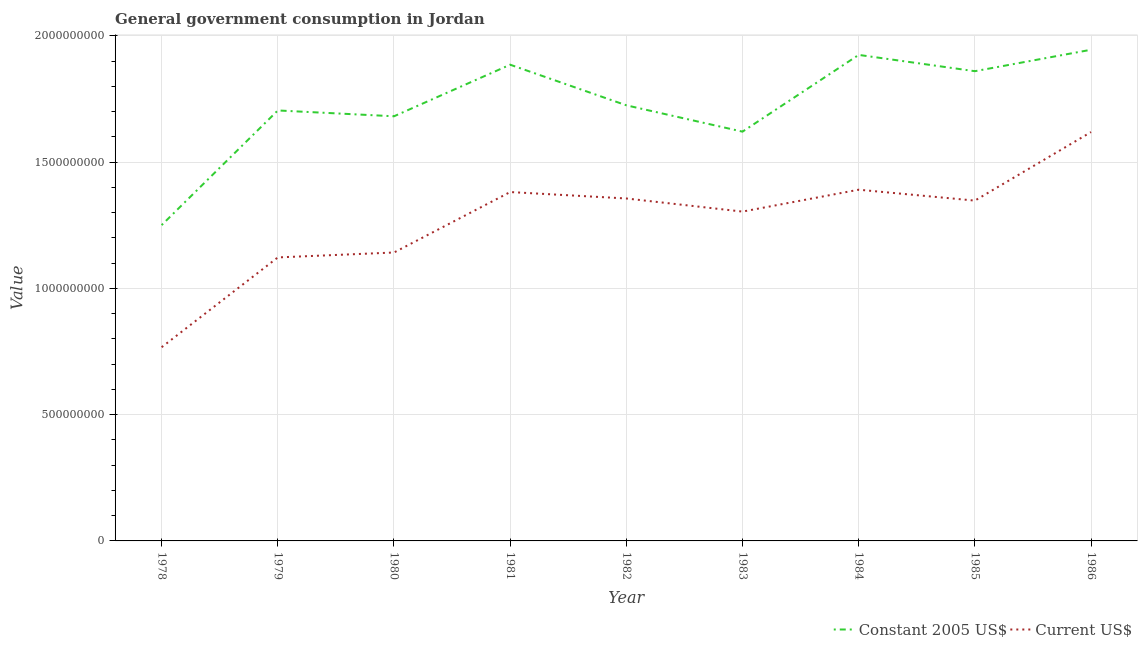Does the line corresponding to value consumed in constant 2005 us$ intersect with the line corresponding to value consumed in current us$?
Make the answer very short. No. Is the number of lines equal to the number of legend labels?
Keep it short and to the point. Yes. What is the value consumed in constant 2005 us$ in 1982?
Offer a terse response. 1.72e+09. Across all years, what is the maximum value consumed in current us$?
Ensure brevity in your answer.  1.62e+09. Across all years, what is the minimum value consumed in current us$?
Give a very brief answer. 7.67e+08. In which year was the value consumed in current us$ maximum?
Your answer should be compact. 1986. In which year was the value consumed in current us$ minimum?
Make the answer very short. 1978. What is the total value consumed in current us$ in the graph?
Ensure brevity in your answer.  1.14e+1. What is the difference between the value consumed in constant 2005 us$ in 1981 and that in 1986?
Ensure brevity in your answer.  -5.92e+07. What is the difference between the value consumed in current us$ in 1984 and the value consumed in constant 2005 us$ in 1983?
Give a very brief answer. -2.30e+08. What is the average value consumed in constant 2005 us$ per year?
Provide a short and direct response. 1.73e+09. In the year 1981, what is the difference between the value consumed in current us$ and value consumed in constant 2005 us$?
Offer a terse response. -5.04e+08. What is the ratio of the value consumed in constant 2005 us$ in 1983 to that in 1984?
Make the answer very short. 0.84. Is the value consumed in current us$ in 1978 less than that in 1979?
Provide a short and direct response. Yes. Is the difference between the value consumed in current us$ in 1979 and 1983 greater than the difference between the value consumed in constant 2005 us$ in 1979 and 1983?
Provide a short and direct response. No. What is the difference between the highest and the second highest value consumed in constant 2005 us$?
Your response must be concise. 2.04e+07. What is the difference between the highest and the lowest value consumed in constant 2005 us$?
Provide a succinct answer. 6.94e+08. Does the value consumed in constant 2005 us$ monotonically increase over the years?
Keep it short and to the point. No. Is the value consumed in constant 2005 us$ strictly greater than the value consumed in current us$ over the years?
Your response must be concise. Yes. How many lines are there?
Offer a terse response. 2. How many years are there in the graph?
Your answer should be compact. 9. What is the difference between two consecutive major ticks on the Y-axis?
Provide a short and direct response. 5.00e+08. Are the values on the major ticks of Y-axis written in scientific E-notation?
Provide a succinct answer. No. Does the graph contain any zero values?
Give a very brief answer. No. Where does the legend appear in the graph?
Make the answer very short. Bottom right. How many legend labels are there?
Give a very brief answer. 2. How are the legend labels stacked?
Ensure brevity in your answer.  Horizontal. What is the title of the graph?
Provide a succinct answer. General government consumption in Jordan. What is the label or title of the Y-axis?
Ensure brevity in your answer.  Value. What is the Value of Constant 2005 US$ in 1978?
Keep it short and to the point. 1.25e+09. What is the Value of Current US$ in 1978?
Offer a terse response. 7.67e+08. What is the Value in Constant 2005 US$ in 1979?
Provide a succinct answer. 1.70e+09. What is the Value of Current US$ in 1979?
Keep it short and to the point. 1.12e+09. What is the Value in Constant 2005 US$ in 1980?
Your answer should be very brief. 1.68e+09. What is the Value of Current US$ in 1980?
Offer a terse response. 1.14e+09. What is the Value of Constant 2005 US$ in 1981?
Provide a succinct answer. 1.89e+09. What is the Value in Current US$ in 1981?
Offer a very short reply. 1.38e+09. What is the Value of Constant 2005 US$ in 1982?
Provide a short and direct response. 1.72e+09. What is the Value of Current US$ in 1982?
Offer a terse response. 1.36e+09. What is the Value in Constant 2005 US$ in 1983?
Make the answer very short. 1.62e+09. What is the Value in Current US$ in 1983?
Provide a succinct answer. 1.30e+09. What is the Value in Constant 2005 US$ in 1984?
Offer a terse response. 1.92e+09. What is the Value in Current US$ in 1984?
Offer a terse response. 1.39e+09. What is the Value of Constant 2005 US$ in 1985?
Ensure brevity in your answer.  1.86e+09. What is the Value of Current US$ in 1985?
Offer a very short reply. 1.35e+09. What is the Value of Constant 2005 US$ in 1986?
Provide a short and direct response. 1.94e+09. What is the Value of Current US$ in 1986?
Provide a short and direct response. 1.62e+09. Across all years, what is the maximum Value in Constant 2005 US$?
Provide a succinct answer. 1.94e+09. Across all years, what is the maximum Value of Current US$?
Offer a terse response. 1.62e+09. Across all years, what is the minimum Value of Constant 2005 US$?
Make the answer very short. 1.25e+09. Across all years, what is the minimum Value in Current US$?
Keep it short and to the point. 7.67e+08. What is the total Value of Constant 2005 US$ in the graph?
Make the answer very short. 1.56e+1. What is the total Value of Current US$ in the graph?
Offer a very short reply. 1.14e+1. What is the difference between the Value in Constant 2005 US$ in 1978 and that in 1979?
Make the answer very short. -4.54e+08. What is the difference between the Value in Current US$ in 1978 and that in 1979?
Provide a short and direct response. -3.55e+08. What is the difference between the Value in Constant 2005 US$ in 1978 and that in 1980?
Provide a succinct answer. -4.31e+08. What is the difference between the Value of Current US$ in 1978 and that in 1980?
Your answer should be very brief. -3.75e+08. What is the difference between the Value in Constant 2005 US$ in 1978 and that in 1981?
Provide a short and direct response. -6.35e+08. What is the difference between the Value of Current US$ in 1978 and that in 1981?
Provide a short and direct response. -6.14e+08. What is the difference between the Value in Constant 2005 US$ in 1978 and that in 1982?
Give a very brief answer. -4.74e+08. What is the difference between the Value in Current US$ in 1978 and that in 1982?
Your response must be concise. -5.89e+08. What is the difference between the Value in Constant 2005 US$ in 1978 and that in 1983?
Ensure brevity in your answer.  -3.70e+08. What is the difference between the Value of Current US$ in 1978 and that in 1983?
Your answer should be very brief. -5.37e+08. What is the difference between the Value in Constant 2005 US$ in 1978 and that in 1984?
Offer a very short reply. -6.74e+08. What is the difference between the Value in Current US$ in 1978 and that in 1984?
Your answer should be very brief. -6.24e+08. What is the difference between the Value in Constant 2005 US$ in 1978 and that in 1985?
Ensure brevity in your answer.  -6.09e+08. What is the difference between the Value of Current US$ in 1978 and that in 1985?
Offer a terse response. -5.80e+08. What is the difference between the Value in Constant 2005 US$ in 1978 and that in 1986?
Your answer should be very brief. -6.94e+08. What is the difference between the Value in Current US$ in 1978 and that in 1986?
Provide a short and direct response. -8.52e+08. What is the difference between the Value in Constant 2005 US$ in 1979 and that in 1980?
Provide a succinct answer. 2.31e+07. What is the difference between the Value of Current US$ in 1979 and that in 1980?
Keep it short and to the point. -1.95e+07. What is the difference between the Value of Constant 2005 US$ in 1979 and that in 1981?
Provide a succinct answer. -1.81e+08. What is the difference between the Value of Current US$ in 1979 and that in 1981?
Your response must be concise. -2.59e+08. What is the difference between the Value of Constant 2005 US$ in 1979 and that in 1982?
Make the answer very short. -2.04e+07. What is the difference between the Value of Current US$ in 1979 and that in 1982?
Your response must be concise. -2.33e+08. What is the difference between the Value of Constant 2005 US$ in 1979 and that in 1983?
Provide a short and direct response. 8.39e+07. What is the difference between the Value of Current US$ in 1979 and that in 1983?
Offer a terse response. -1.81e+08. What is the difference between the Value in Constant 2005 US$ in 1979 and that in 1984?
Your response must be concise. -2.20e+08. What is the difference between the Value in Current US$ in 1979 and that in 1984?
Your response must be concise. -2.68e+08. What is the difference between the Value of Constant 2005 US$ in 1979 and that in 1985?
Your response must be concise. -1.55e+08. What is the difference between the Value in Current US$ in 1979 and that in 1985?
Keep it short and to the point. -2.25e+08. What is the difference between the Value in Constant 2005 US$ in 1979 and that in 1986?
Offer a very short reply. -2.40e+08. What is the difference between the Value in Current US$ in 1979 and that in 1986?
Provide a short and direct response. -4.96e+08. What is the difference between the Value in Constant 2005 US$ in 1980 and that in 1981?
Make the answer very short. -2.04e+08. What is the difference between the Value of Current US$ in 1980 and that in 1981?
Make the answer very short. -2.39e+08. What is the difference between the Value in Constant 2005 US$ in 1980 and that in 1982?
Your response must be concise. -4.34e+07. What is the difference between the Value of Current US$ in 1980 and that in 1982?
Ensure brevity in your answer.  -2.14e+08. What is the difference between the Value in Constant 2005 US$ in 1980 and that in 1983?
Provide a succinct answer. 6.08e+07. What is the difference between the Value in Current US$ in 1980 and that in 1983?
Ensure brevity in your answer.  -1.62e+08. What is the difference between the Value in Constant 2005 US$ in 1980 and that in 1984?
Your response must be concise. -2.43e+08. What is the difference between the Value in Current US$ in 1980 and that in 1984?
Give a very brief answer. -2.49e+08. What is the difference between the Value in Constant 2005 US$ in 1980 and that in 1985?
Your answer should be very brief. -1.79e+08. What is the difference between the Value of Current US$ in 1980 and that in 1985?
Keep it short and to the point. -2.05e+08. What is the difference between the Value of Constant 2005 US$ in 1980 and that in 1986?
Your response must be concise. -2.63e+08. What is the difference between the Value in Current US$ in 1980 and that in 1986?
Offer a terse response. -4.77e+08. What is the difference between the Value in Constant 2005 US$ in 1981 and that in 1982?
Offer a very short reply. 1.61e+08. What is the difference between the Value of Current US$ in 1981 and that in 1982?
Make the answer very short. 2.54e+07. What is the difference between the Value of Constant 2005 US$ in 1981 and that in 1983?
Keep it short and to the point. 2.65e+08. What is the difference between the Value of Current US$ in 1981 and that in 1983?
Your answer should be compact. 7.74e+07. What is the difference between the Value of Constant 2005 US$ in 1981 and that in 1984?
Keep it short and to the point. -3.88e+07. What is the difference between the Value in Current US$ in 1981 and that in 1984?
Give a very brief answer. -9.29e+06. What is the difference between the Value of Constant 2005 US$ in 1981 and that in 1985?
Provide a short and direct response. 2.57e+07. What is the difference between the Value of Current US$ in 1981 and that in 1985?
Offer a terse response. 3.39e+07. What is the difference between the Value in Constant 2005 US$ in 1981 and that in 1986?
Provide a succinct answer. -5.92e+07. What is the difference between the Value of Current US$ in 1981 and that in 1986?
Give a very brief answer. -2.38e+08. What is the difference between the Value of Constant 2005 US$ in 1982 and that in 1983?
Your answer should be very brief. 1.04e+08. What is the difference between the Value in Current US$ in 1982 and that in 1983?
Provide a succinct answer. 5.19e+07. What is the difference between the Value in Constant 2005 US$ in 1982 and that in 1984?
Your answer should be very brief. -2.00e+08. What is the difference between the Value of Current US$ in 1982 and that in 1984?
Offer a terse response. -3.47e+07. What is the difference between the Value in Constant 2005 US$ in 1982 and that in 1985?
Your answer should be compact. -1.35e+08. What is the difference between the Value of Current US$ in 1982 and that in 1985?
Your response must be concise. 8.42e+06. What is the difference between the Value in Constant 2005 US$ in 1982 and that in 1986?
Keep it short and to the point. -2.20e+08. What is the difference between the Value of Current US$ in 1982 and that in 1986?
Your answer should be compact. -2.63e+08. What is the difference between the Value of Constant 2005 US$ in 1983 and that in 1984?
Offer a very short reply. -3.04e+08. What is the difference between the Value in Current US$ in 1983 and that in 1984?
Your answer should be very brief. -8.67e+07. What is the difference between the Value in Constant 2005 US$ in 1983 and that in 1985?
Give a very brief answer. -2.39e+08. What is the difference between the Value of Current US$ in 1983 and that in 1985?
Offer a very short reply. -4.35e+07. What is the difference between the Value of Constant 2005 US$ in 1983 and that in 1986?
Your answer should be compact. -3.24e+08. What is the difference between the Value of Current US$ in 1983 and that in 1986?
Give a very brief answer. -3.15e+08. What is the difference between the Value of Constant 2005 US$ in 1984 and that in 1985?
Offer a terse response. 6.45e+07. What is the difference between the Value in Current US$ in 1984 and that in 1985?
Ensure brevity in your answer.  4.31e+07. What is the difference between the Value of Constant 2005 US$ in 1984 and that in 1986?
Provide a succinct answer. -2.04e+07. What is the difference between the Value of Current US$ in 1984 and that in 1986?
Keep it short and to the point. -2.28e+08. What is the difference between the Value of Constant 2005 US$ in 1985 and that in 1986?
Make the answer very short. -8.49e+07. What is the difference between the Value in Current US$ in 1985 and that in 1986?
Your answer should be compact. -2.71e+08. What is the difference between the Value in Constant 2005 US$ in 1978 and the Value in Current US$ in 1979?
Provide a short and direct response. 1.28e+08. What is the difference between the Value of Constant 2005 US$ in 1978 and the Value of Current US$ in 1980?
Offer a very short reply. 1.08e+08. What is the difference between the Value in Constant 2005 US$ in 1978 and the Value in Current US$ in 1981?
Your response must be concise. -1.31e+08. What is the difference between the Value in Constant 2005 US$ in 1978 and the Value in Current US$ in 1982?
Offer a very short reply. -1.05e+08. What is the difference between the Value of Constant 2005 US$ in 1978 and the Value of Current US$ in 1983?
Ensure brevity in your answer.  -5.35e+07. What is the difference between the Value in Constant 2005 US$ in 1978 and the Value in Current US$ in 1984?
Keep it short and to the point. -1.40e+08. What is the difference between the Value in Constant 2005 US$ in 1978 and the Value in Current US$ in 1985?
Your response must be concise. -9.70e+07. What is the difference between the Value of Constant 2005 US$ in 1978 and the Value of Current US$ in 1986?
Keep it short and to the point. -3.68e+08. What is the difference between the Value in Constant 2005 US$ in 1979 and the Value in Current US$ in 1980?
Provide a short and direct response. 5.62e+08. What is the difference between the Value of Constant 2005 US$ in 1979 and the Value of Current US$ in 1981?
Provide a short and direct response. 3.23e+08. What is the difference between the Value of Constant 2005 US$ in 1979 and the Value of Current US$ in 1982?
Your answer should be compact. 3.48e+08. What is the difference between the Value of Constant 2005 US$ in 1979 and the Value of Current US$ in 1983?
Ensure brevity in your answer.  4.00e+08. What is the difference between the Value in Constant 2005 US$ in 1979 and the Value in Current US$ in 1984?
Offer a terse response. 3.14e+08. What is the difference between the Value of Constant 2005 US$ in 1979 and the Value of Current US$ in 1985?
Your response must be concise. 3.57e+08. What is the difference between the Value in Constant 2005 US$ in 1979 and the Value in Current US$ in 1986?
Give a very brief answer. 8.55e+07. What is the difference between the Value of Constant 2005 US$ in 1980 and the Value of Current US$ in 1981?
Your answer should be compact. 3.00e+08. What is the difference between the Value in Constant 2005 US$ in 1980 and the Value in Current US$ in 1982?
Your answer should be compact. 3.25e+08. What is the difference between the Value of Constant 2005 US$ in 1980 and the Value of Current US$ in 1983?
Your answer should be compact. 3.77e+08. What is the difference between the Value of Constant 2005 US$ in 1980 and the Value of Current US$ in 1984?
Ensure brevity in your answer.  2.91e+08. What is the difference between the Value in Constant 2005 US$ in 1980 and the Value in Current US$ in 1985?
Your answer should be compact. 3.34e+08. What is the difference between the Value in Constant 2005 US$ in 1980 and the Value in Current US$ in 1986?
Give a very brief answer. 6.25e+07. What is the difference between the Value in Constant 2005 US$ in 1981 and the Value in Current US$ in 1982?
Your answer should be compact. 5.30e+08. What is the difference between the Value of Constant 2005 US$ in 1981 and the Value of Current US$ in 1983?
Provide a succinct answer. 5.82e+08. What is the difference between the Value in Constant 2005 US$ in 1981 and the Value in Current US$ in 1984?
Give a very brief answer. 4.95e+08. What is the difference between the Value of Constant 2005 US$ in 1981 and the Value of Current US$ in 1985?
Your response must be concise. 5.38e+08. What is the difference between the Value of Constant 2005 US$ in 1981 and the Value of Current US$ in 1986?
Offer a terse response. 2.67e+08. What is the difference between the Value in Constant 2005 US$ in 1982 and the Value in Current US$ in 1983?
Provide a short and direct response. 4.21e+08. What is the difference between the Value in Constant 2005 US$ in 1982 and the Value in Current US$ in 1984?
Provide a short and direct response. 3.34e+08. What is the difference between the Value of Constant 2005 US$ in 1982 and the Value of Current US$ in 1985?
Offer a terse response. 3.77e+08. What is the difference between the Value in Constant 2005 US$ in 1982 and the Value in Current US$ in 1986?
Make the answer very short. 1.06e+08. What is the difference between the Value in Constant 2005 US$ in 1983 and the Value in Current US$ in 1984?
Ensure brevity in your answer.  2.30e+08. What is the difference between the Value in Constant 2005 US$ in 1983 and the Value in Current US$ in 1985?
Your response must be concise. 2.73e+08. What is the difference between the Value in Constant 2005 US$ in 1983 and the Value in Current US$ in 1986?
Your answer should be very brief. 1.63e+06. What is the difference between the Value in Constant 2005 US$ in 1984 and the Value in Current US$ in 1985?
Provide a succinct answer. 5.77e+08. What is the difference between the Value of Constant 2005 US$ in 1984 and the Value of Current US$ in 1986?
Ensure brevity in your answer.  3.06e+08. What is the difference between the Value of Constant 2005 US$ in 1985 and the Value of Current US$ in 1986?
Provide a short and direct response. 2.41e+08. What is the average Value of Constant 2005 US$ per year?
Your answer should be very brief. 1.73e+09. What is the average Value in Current US$ per year?
Provide a succinct answer. 1.27e+09. In the year 1978, what is the difference between the Value of Constant 2005 US$ and Value of Current US$?
Provide a short and direct response. 4.83e+08. In the year 1979, what is the difference between the Value in Constant 2005 US$ and Value in Current US$?
Provide a succinct answer. 5.82e+08. In the year 1980, what is the difference between the Value in Constant 2005 US$ and Value in Current US$?
Your response must be concise. 5.39e+08. In the year 1981, what is the difference between the Value of Constant 2005 US$ and Value of Current US$?
Keep it short and to the point. 5.04e+08. In the year 1982, what is the difference between the Value of Constant 2005 US$ and Value of Current US$?
Provide a short and direct response. 3.69e+08. In the year 1983, what is the difference between the Value of Constant 2005 US$ and Value of Current US$?
Keep it short and to the point. 3.17e+08. In the year 1984, what is the difference between the Value in Constant 2005 US$ and Value in Current US$?
Your answer should be compact. 5.34e+08. In the year 1985, what is the difference between the Value in Constant 2005 US$ and Value in Current US$?
Your answer should be very brief. 5.12e+08. In the year 1986, what is the difference between the Value of Constant 2005 US$ and Value of Current US$?
Give a very brief answer. 3.26e+08. What is the ratio of the Value in Constant 2005 US$ in 1978 to that in 1979?
Give a very brief answer. 0.73. What is the ratio of the Value in Current US$ in 1978 to that in 1979?
Your response must be concise. 0.68. What is the ratio of the Value in Constant 2005 US$ in 1978 to that in 1980?
Provide a short and direct response. 0.74. What is the ratio of the Value of Current US$ in 1978 to that in 1980?
Your answer should be very brief. 0.67. What is the ratio of the Value in Constant 2005 US$ in 1978 to that in 1981?
Keep it short and to the point. 0.66. What is the ratio of the Value in Current US$ in 1978 to that in 1981?
Provide a succinct answer. 0.56. What is the ratio of the Value of Constant 2005 US$ in 1978 to that in 1982?
Offer a very short reply. 0.72. What is the ratio of the Value in Current US$ in 1978 to that in 1982?
Your answer should be very brief. 0.57. What is the ratio of the Value in Constant 2005 US$ in 1978 to that in 1983?
Provide a succinct answer. 0.77. What is the ratio of the Value in Current US$ in 1978 to that in 1983?
Offer a terse response. 0.59. What is the ratio of the Value in Constant 2005 US$ in 1978 to that in 1984?
Ensure brevity in your answer.  0.65. What is the ratio of the Value of Current US$ in 1978 to that in 1984?
Give a very brief answer. 0.55. What is the ratio of the Value in Constant 2005 US$ in 1978 to that in 1985?
Your answer should be very brief. 0.67. What is the ratio of the Value of Current US$ in 1978 to that in 1985?
Offer a terse response. 0.57. What is the ratio of the Value in Constant 2005 US$ in 1978 to that in 1986?
Provide a succinct answer. 0.64. What is the ratio of the Value of Current US$ in 1978 to that in 1986?
Keep it short and to the point. 0.47. What is the ratio of the Value in Constant 2005 US$ in 1979 to that in 1980?
Ensure brevity in your answer.  1.01. What is the ratio of the Value of Current US$ in 1979 to that in 1980?
Offer a terse response. 0.98. What is the ratio of the Value in Constant 2005 US$ in 1979 to that in 1981?
Your answer should be very brief. 0.9. What is the ratio of the Value of Current US$ in 1979 to that in 1981?
Your answer should be compact. 0.81. What is the ratio of the Value in Current US$ in 1979 to that in 1982?
Your answer should be compact. 0.83. What is the ratio of the Value in Constant 2005 US$ in 1979 to that in 1983?
Offer a terse response. 1.05. What is the ratio of the Value in Current US$ in 1979 to that in 1983?
Offer a very short reply. 0.86. What is the ratio of the Value in Constant 2005 US$ in 1979 to that in 1984?
Offer a terse response. 0.89. What is the ratio of the Value of Current US$ in 1979 to that in 1984?
Your response must be concise. 0.81. What is the ratio of the Value in Constant 2005 US$ in 1979 to that in 1985?
Your response must be concise. 0.92. What is the ratio of the Value of Current US$ in 1979 to that in 1985?
Provide a succinct answer. 0.83. What is the ratio of the Value in Constant 2005 US$ in 1979 to that in 1986?
Offer a terse response. 0.88. What is the ratio of the Value in Current US$ in 1979 to that in 1986?
Provide a short and direct response. 0.69. What is the ratio of the Value in Constant 2005 US$ in 1980 to that in 1981?
Your response must be concise. 0.89. What is the ratio of the Value in Current US$ in 1980 to that in 1981?
Keep it short and to the point. 0.83. What is the ratio of the Value in Constant 2005 US$ in 1980 to that in 1982?
Ensure brevity in your answer.  0.97. What is the ratio of the Value of Current US$ in 1980 to that in 1982?
Provide a succinct answer. 0.84. What is the ratio of the Value in Constant 2005 US$ in 1980 to that in 1983?
Your response must be concise. 1.04. What is the ratio of the Value of Current US$ in 1980 to that in 1983?
Make the answer very short. 0.88. What is the ratio of the Value in Constant 2005 US$ in 1980 to that in 1984?
Provide a succinct answer. 0.87. What is the ratio of the Value of Current US$ in 1980 to that in 1984?
Your answer should be very brief. 0.82. What is the ratio of the Value of Constant 2005 US$ in 1980 to that in 1985?
Offer a very short reply. 0.9. What is the ratio of the Value of Current US$ in 1980 to that in 1985?
Keep it short and to the point. 0.85. What is the ratio of the Value in Constant 2005 US$ in 1980 to that in 1986?
Your answer should be very brief. 0.86. What is the ratio of the Value in Current US$ in 1980 to that in 1986?
Your response must be concise. 0.71. What is the ratio of the Value of Constant 2005 US$ in 1981 to that in 1982?
Provide a succinct answer. 1.09. What is the ratio of the Value in Current US$ in 1981 to that in 1982?
Make the answer very short. 1.02. What is the ratio of the Value in Constant 2005 US$ in 1981 to that in 1983?
Keep it short and to the point. 1.16. What is the ratio of the Value in Current US$ in 1981 to that in 1983?
Your response must be concise. 1.06. What is the ratio of the Value in Constant 2005 US$ in 1981 to that in 1984?
Your response must be concise. 0.98. What is the ratio of the Value in Current US$ in 1981 to that in 1984?
Keep it short and to the point. 0.99. What is the ratio of the Value in Constant 2005 US$ in 1981 to that in 1985?
Offer a very short reply. 1.01. What is the ratio of the Value of Current US$ in 1981 to that in 1985?
Provide a succinct answer. 1.03. What is the ratio of the Value in Constant 2005 US$ in 1981 to that in 1986?
Provide a succinct answer. 0.97. What is the ratio of the Value in Current US$ in 1981 to that in 1986?
Offer a terse response. 0.85. What is the ratio of the Value of Constant 2005 US$ in 1982 to that in 1983?
Your response must be concise. 1.06. What is the ratio of the Value in Current US$ in 1982 to that in 1983?
Provide a succinct answer. 1.04. What is the ratio of the Value in Constant 2005 US$ in 1982 to that in 1984?
Your response must be concise. 0.9. What is the ratio of the Value of Current US$ in 1982 to that in 1984?
Offer a terse response. 0.97. What is the ratio of the Value of Constant 2005 US$ in 1982 to that in 1985?
Keep it short and to the point. 0.93. What is the ratio of the Value in Constant 2005 US$ in 1982 to that in 1986?
Give a very brief answer. 0.89. What is the ratio of the Value of Current US$ in 1982 to that in 1986?
Your answer should be compact. 0.84. What is the ratio of the Value in Constant 2005 US$ in 1983 to that in 1984?
Keep it short and to the point. 0.84. What is the ratio of the Value in Current US$ in 1983 to that in 1984?
Ensure brevity in your answer.  0.94. What is the ratio of the Value of Constant 2005 US$ in 1983 to that in 1985?
Keep it short and to the point. 0.87. What is the ratio of the Value in Current US$ in 1983 to that in 1986?
Make the answer very short. 0.81. What is the ratio of the Value in Constant 2005 US$ in 1984 to that in 1985?
Give a very brief answer. 1.03. What is the ratio of the Value in Current US$ in 1984 to that in 1985?
Your answer should be compact. 1.03. What is the ratio of the Value of Current US$ in 1984 to that in 1986?
Your response must be concise. 0.86. What is the ratio of the Value of Constant 2005 US$ in 1985 to that in 1986?
Provide a succinct answer. 0.96. What is the ratio of the Value of Current US$ in 1985 to that in 1986?
Offer a very short reply. 0.83. What is the difference between the highest and the second highest Value in Constant 2005 US$?
Offer a very short reply. 2.04e+07. What is the difference between the highest and the second highest Value of Current US$?
Your answer should be compact. 2.28e+08. What is the difference between the highest and the lowest Value in Constant 2005 US$?
Your answer should be compact. 6.94e+08. What is the difference between the highest and the lowest Value of Current US$?
Keep it short and to the point. 8.52e+08. 